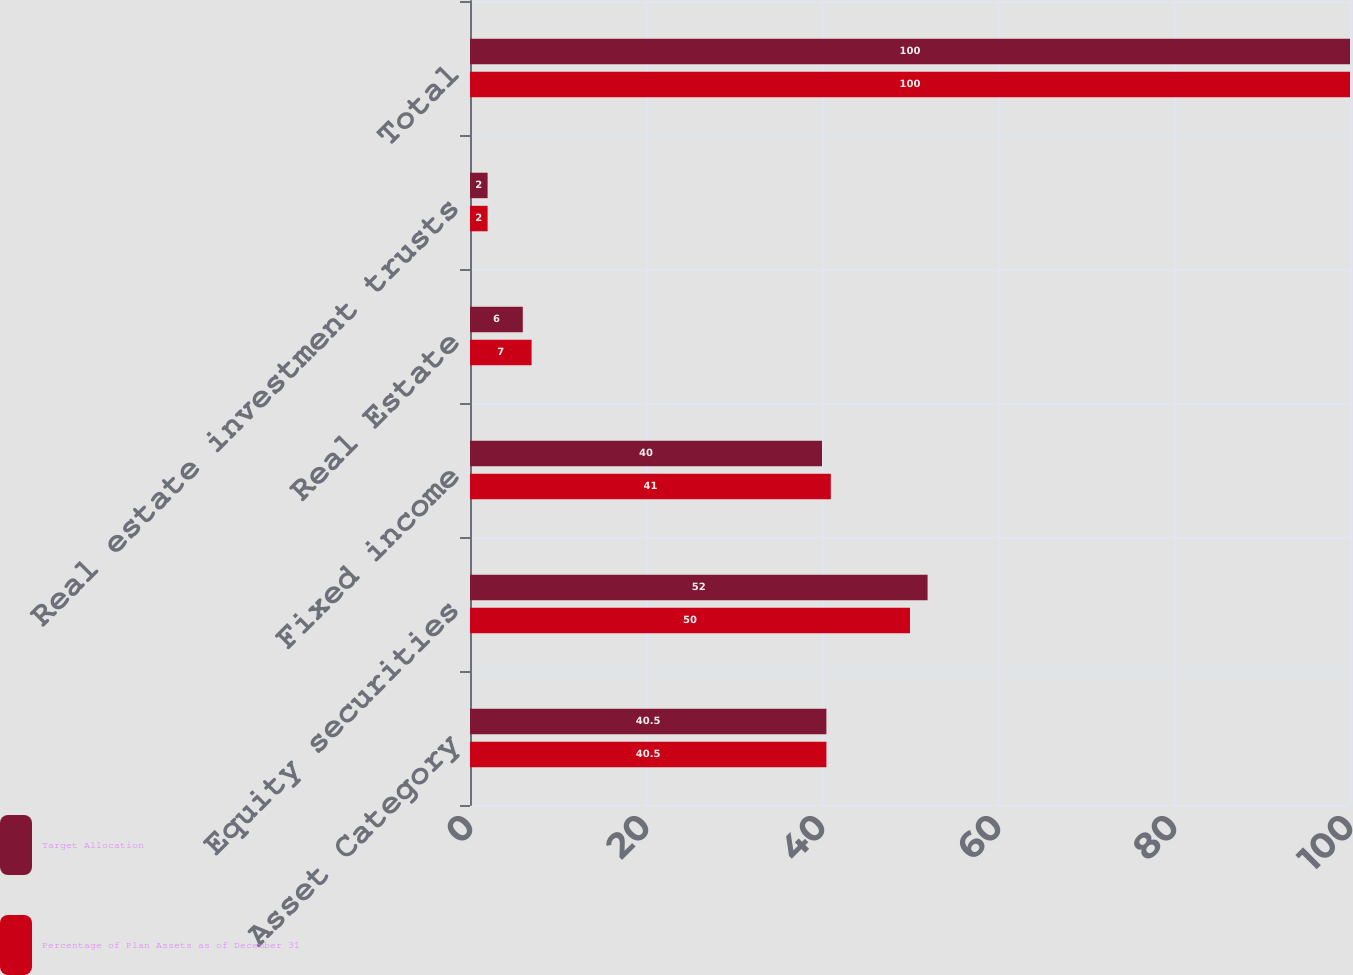Convert chart to OTSL. <chart><loc_0><loc_0><loc_500><loc_500><stacked_bar_chart><ecel><fcel>Asset Category<fcel>Equity securities<fcel>Fixed income<fcel>Real Estate<fcel>Real estate investment trusts<fcel>Total<nl><fcel>Target Allocation<fcel>40.5<fcel>52<fcel>40<fcel>6<fcel>2<fcel>100<nl><fcel>Percentage of Plan Assets as of December 31<fcel>40.5<fcel>50<fcel>41<fcel>7<fcel>2<fcel>100<nl></chart> 